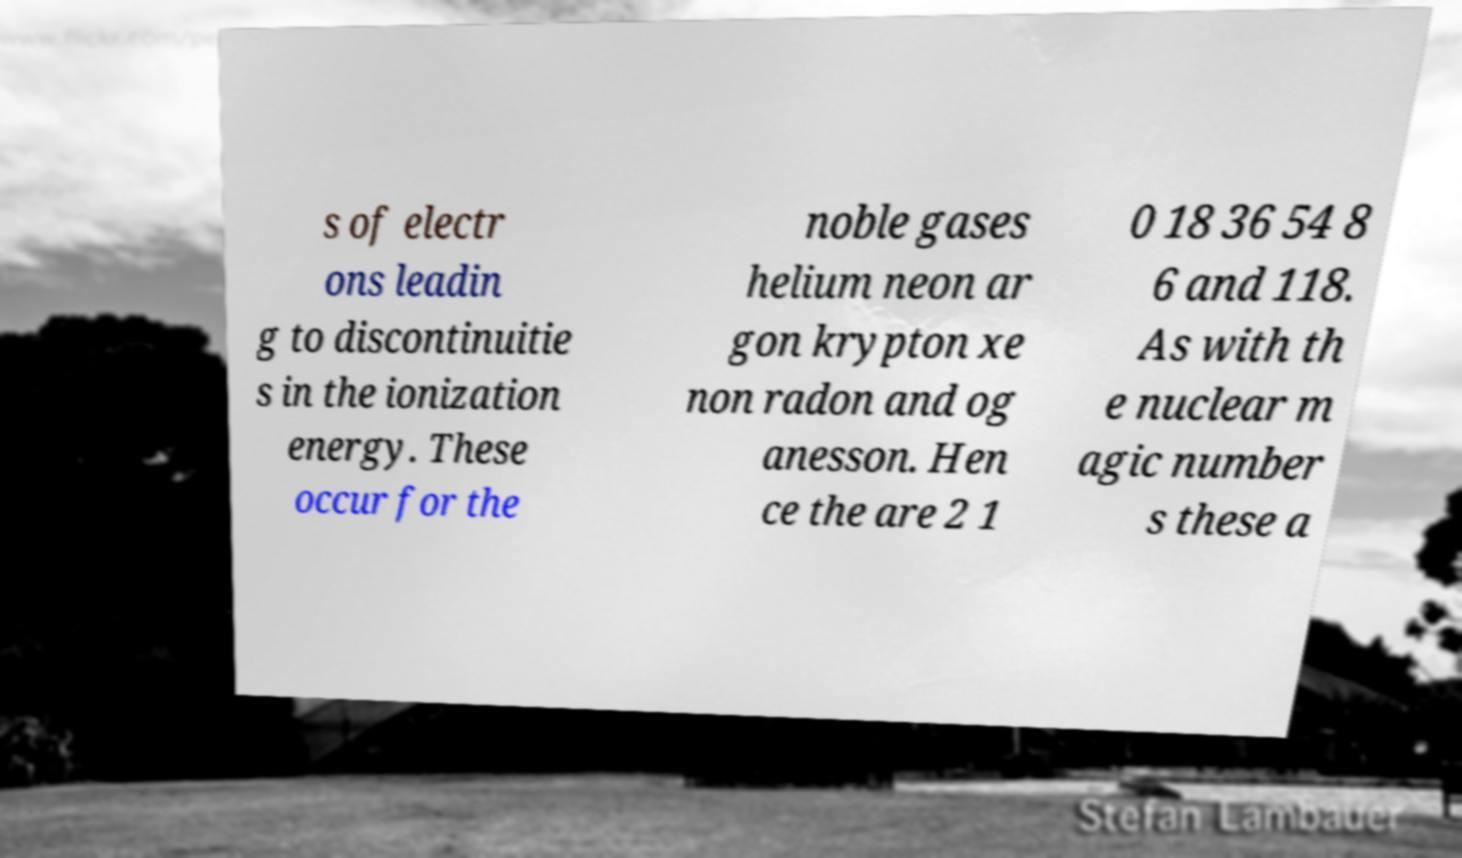Could you extract and type out the text from this image? s of electr ons leadin g to discontinuitie s in the ionization energy. These occur for the noble gases helium neon ar gon krypton xe non radon and og anesson. Hen ce the are 2 1 0 18 36 54 8 6 and 118. As with th e nuclear m agic number s these a 